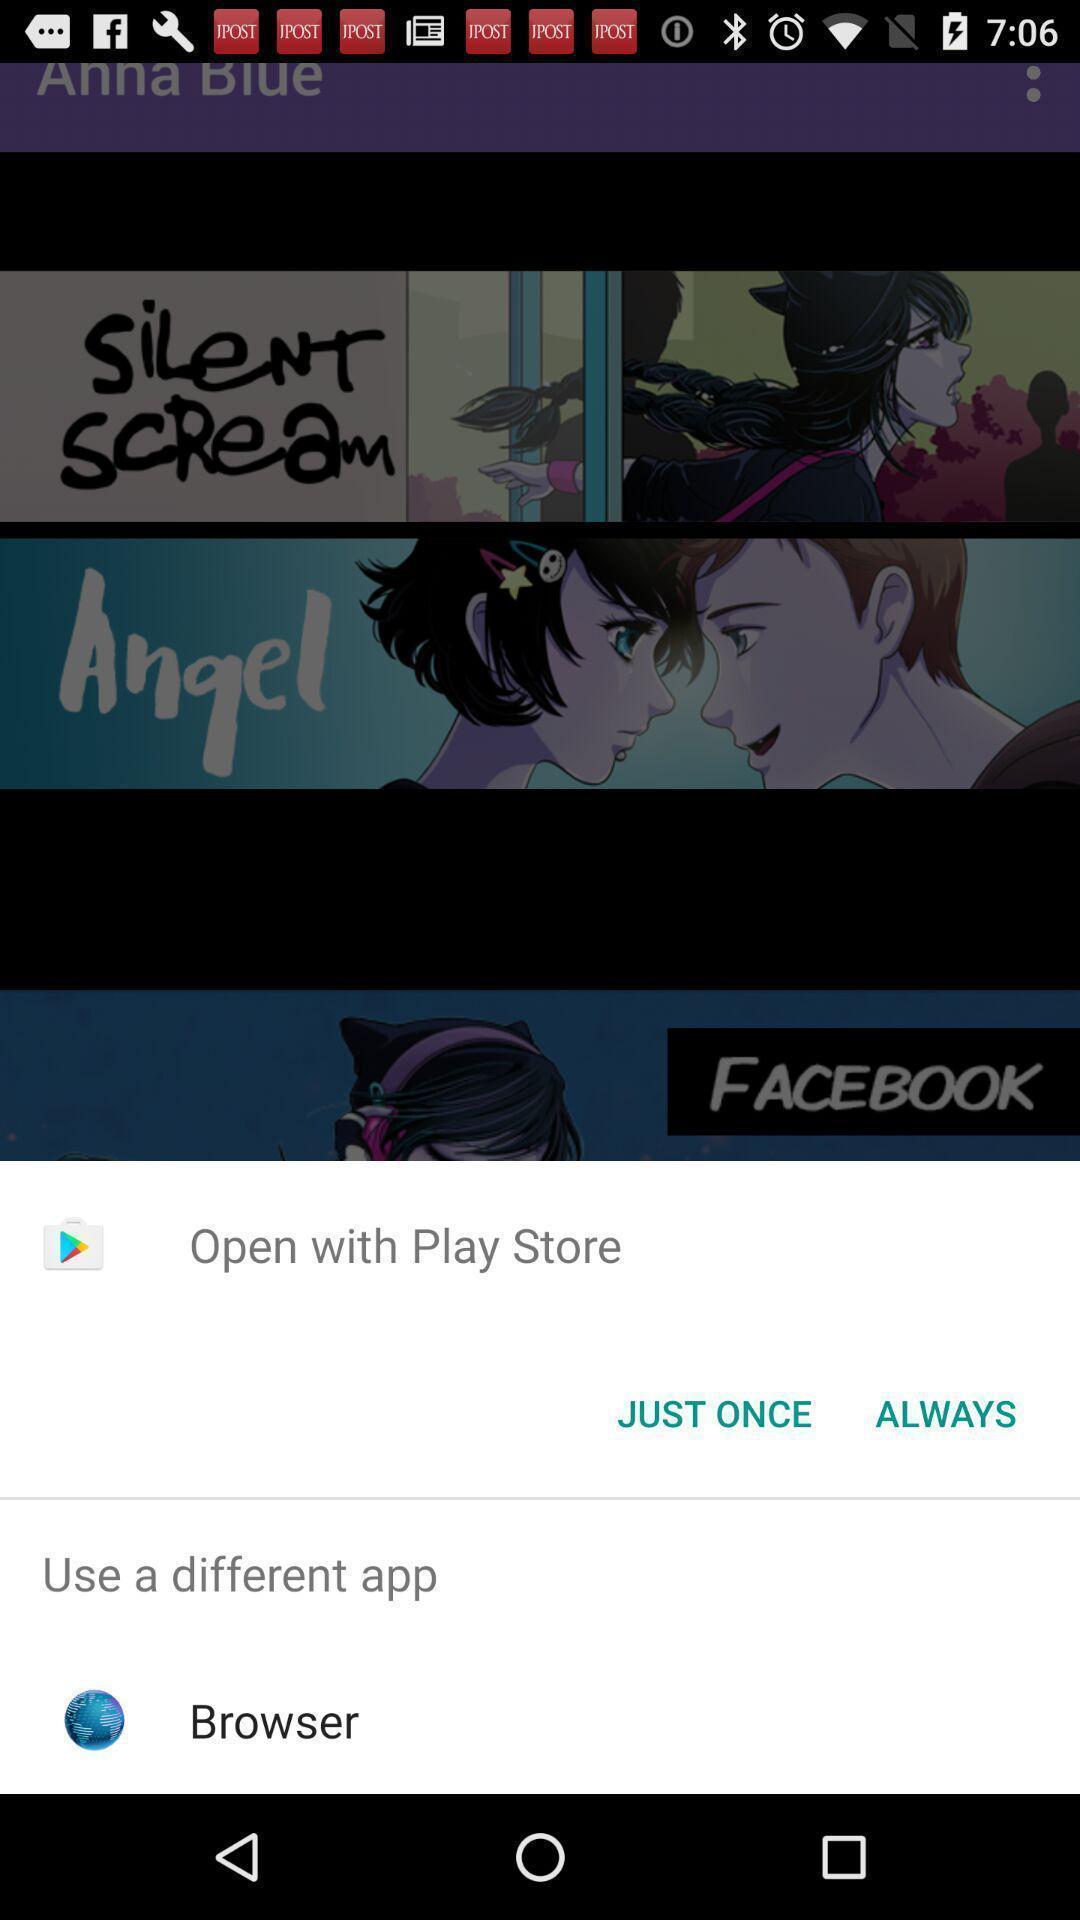Give me a narrative description of this picture. Push up message showing open with option. 